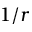<formula> <loc_0><loc_0><loc_500><loc_500>1 / r</formula> 